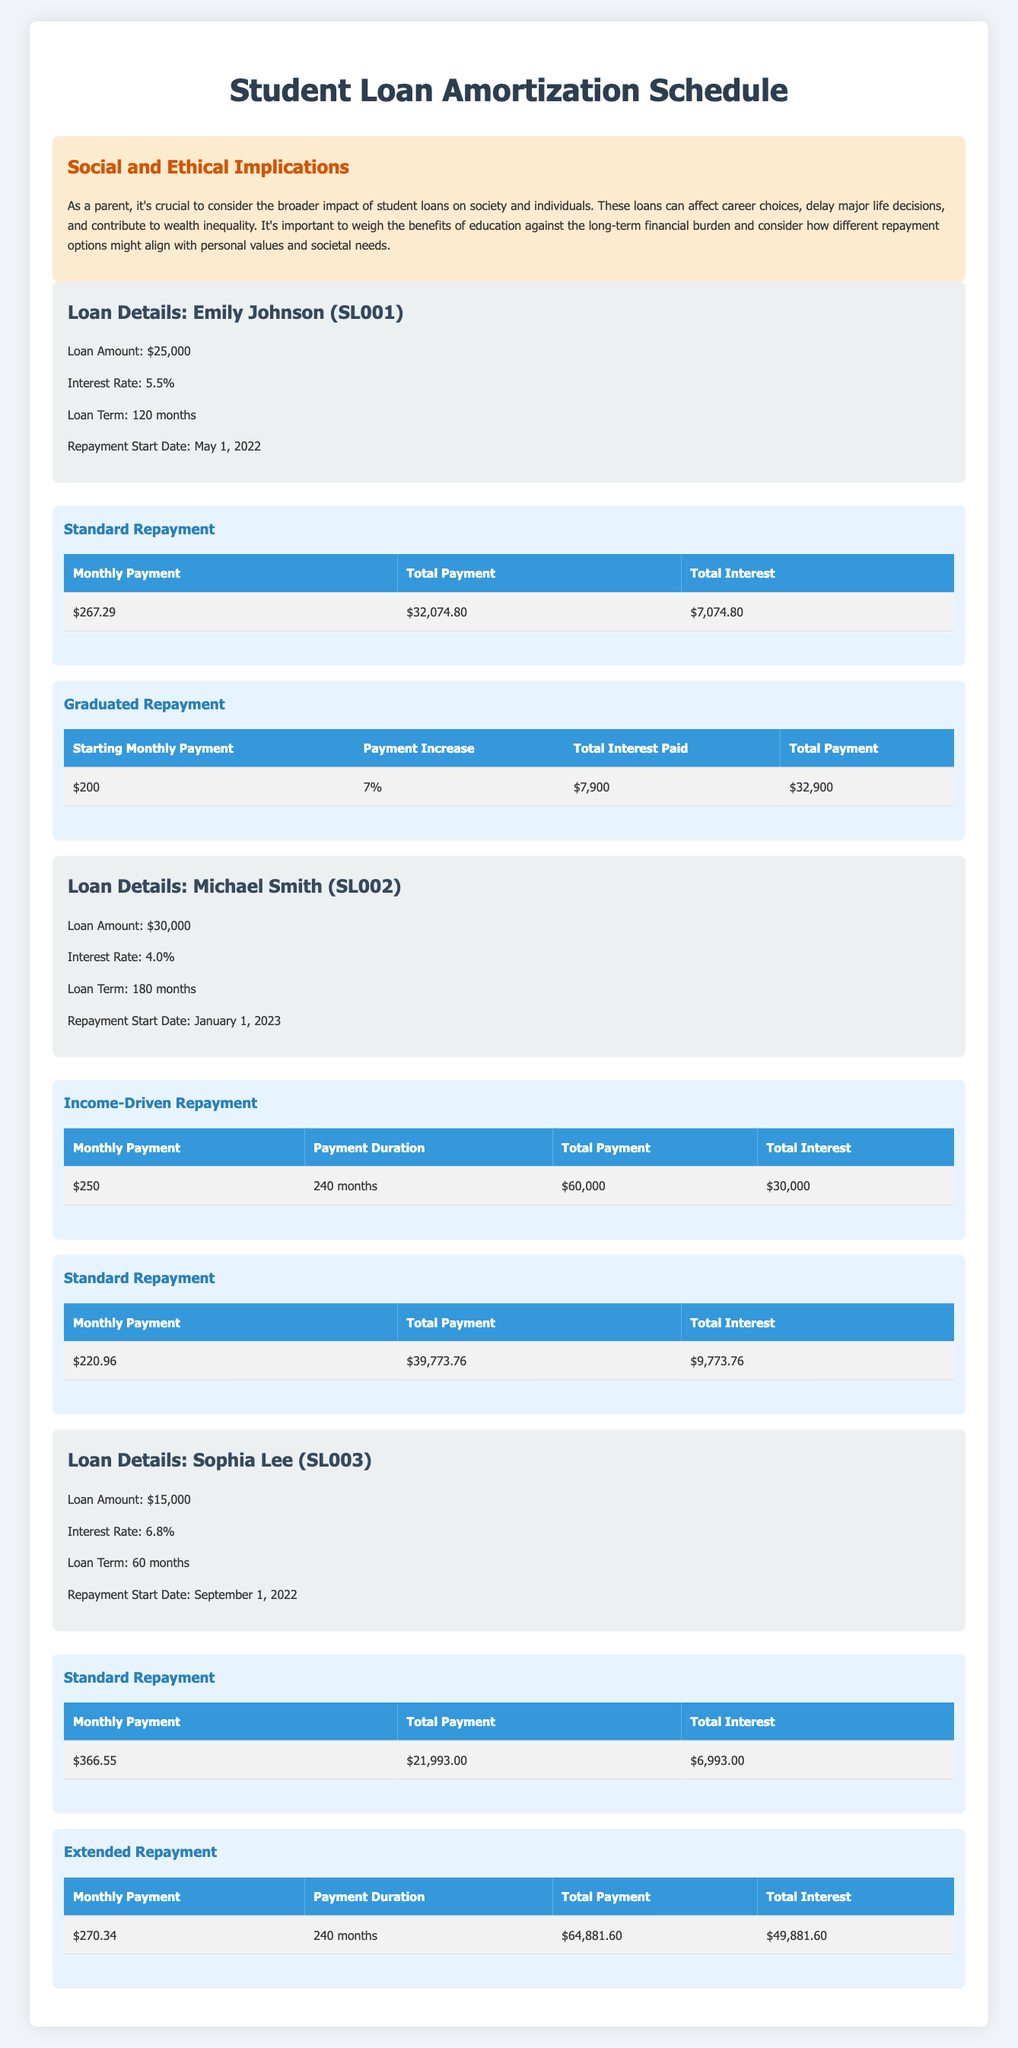What is the total payment for Emily Johnson's loan using the Standard Repayment option? The table indicates that the total payment for Emily Johnson under the Standard Repayment option is $32,074.80.
Answer: $32,074.80 What is the interest rate for Michael Smith's loan? The table lists the interest rate for Michael Smith's loan as 4.0%.
Answer: 4.0% How much total interest would Sophia Lee pay if she chose the Extended Repayment option? According to the table, the total interest paid under the Extended Repayment option for Sophia Lee is $49,881.60.
Answer: $49,881.60 Which repayment option for Emily Johnson leads to a higher total payment: Standard or Graduated Repayment? The Standard Repayment total payment is $32,074.80, while the Graduated Repayment total payment is $32,900. Therefore, the Graduated option results in a higher total payment.
Answer: Graduated Repayment What is the payment duration in months for Michael Smith's Income-Driven Repayment option? The table specifies that the payment duration for Michael Smith’s Income-Driven Repayment option is 240 months.
Answer: 240 months Which borrower has the highest initial monthly payment under the Standard Repayment plan? Comparing the Standard Repayment monthly payments shows that Emily Johnson pays $267.29, Michael Smith pays $220.96, and Sophia Lee pays $366.55. Therefore, Sophia Lee has the highest initial monthly payment.
Answer: Sophia Lee What is the difference between the total interest paid by Michael Smith under Income-Driven Repayment and Standard Repayment? Michael Smith’s total interest for Income-Driven Repayment is $30,000 and for Standard Repayment, it's $9,773.76. The difference is $30,000 - $9,773.76 = $20,226.24.
Answer: $20,226.24 Is the total payment under the Standard Repayment option for Sophia Lee less than that for Emily Johnson? The total payment for Sophia Lee under Standard Repayment is $21,993.00, and for Emily Johnson, it is $32,074.80. Since $21,993.00 is less than $32,074.80, the statement is true.
Answer: Yes What would be the cumulative total payment for Emily Johnson and Michael Smith if both chose the Standard Repayment option? Emily Johnson's total payment under Standard Repayment is $32,074.80. Michael Smith's total payment under Standard Repayment is $39,773.76. Summing these gives $32,074.80 + $39,773.76 = $71,848.56.
Answer: $71,848.56 